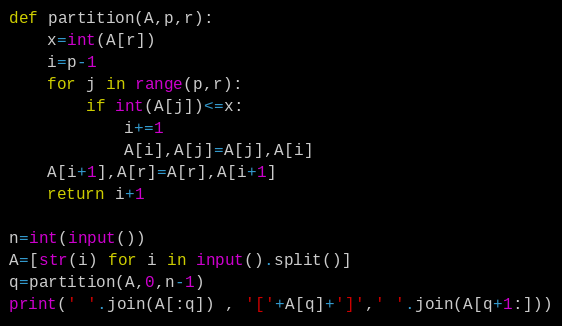Convert code to text. <code><loc_0><loc_0><loc_500><loc_500><_Python_>def partition(A,p,r):
    x=int(A[r])
    i=p-1
    for j in range(p,r):
        if int(A[j])<=x:
            i+=1
            A[i],A[j]=A[j],A[i]
    A[i+1],A[r]=A[r],A[i+1]
    return i+1

n=int(input())
A=[str(i) for i in input().split()]
q=partition(A,0,n-1)
print(' '.join(A[:q]) , '['+A[q]+']',' '.join(A[q+1:]))
</code> 